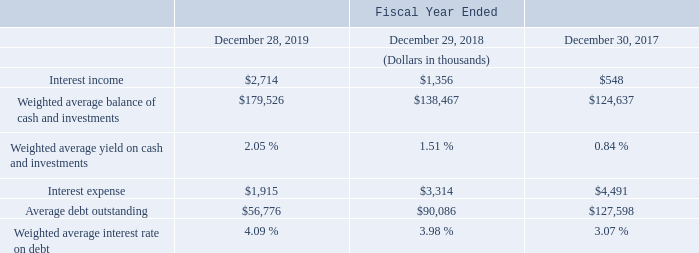Interest Income and Interest Expense
Interest income is earned on our cash, cash equivalents, restricted cash and marketable securities. The increase in interest income in fiscal 2019 compared to fiscal 2018 was attributable to higher investment yields, related in part to longer duration investments, as well as higher average investment balances.
Interest expense primarily includes interest on our term loans, partially offset by income from our interest-rate swap derivative contracts, as well as term loan issuance costs amortization charges. The decrease in interest expense in fiscal 2019 compared to fiscal 2018 was primarily due to lower outstanding debt balances related to the CMI acquisition as a result of principal payments made, partially offset by additional interest expense related to the term loan originated to finance the acquisition of FRT.
Other Income (Expense), Net
Other income (expense), net primarily includes the effects of foreign currency impact and various other gains and losses.
How is Interest income earned? On our cash, cash equivalents, restricted cash and marketable securities. What is the change in Interest income from Fiscal Year Ended December 28, 2019 to December 29, 2018?
Answer scale should be: thousand. 2,714-1,356
Answer: 1358. What is the change in Weighted average balance of cash and investments from Fiscal Year Ended December 28, 2019 to December 29, 2018?
Answer scale should be: thousand. 179,526-138,467
Answer: 41059. In which year was Interest income less than 1,000 thousands? Locate and analyze interest income in row 4
answer: 2017. What was the Weighted average balance of cash and investments in 2019 and 2018 respectively?
Answer scale should be: thousand. $179,526, $138,467. What does interest expense include? Interest on our term loans, partially offset by income from our interest-rate swap derivative contracts, as well as term loan issuance costs amortization charges. 